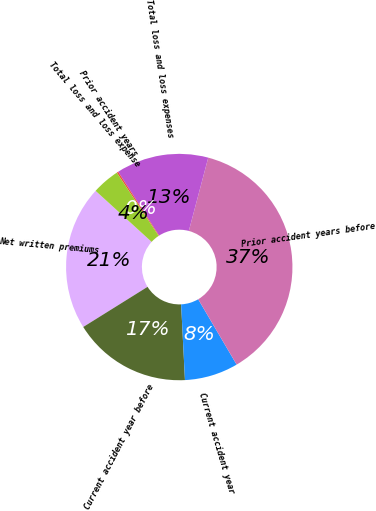<chart> <loc_0><loc_0><loc_500><loc_500><pie_chart><fcel>Net written premiums<fcel>Current accident year before<fcel>Current accident year<fcel>Prior accident years before<fcel>Total loss and loss expenses<fcel>Prior accident years<fcel>Total loss and loss expense<nl><fcel>20.64%<fcel>16.92%<fcel>7.66%<fcel>37.41%<fcel>13.2%<fcel>0.22%<fcel>3.94%<nl></chart> 